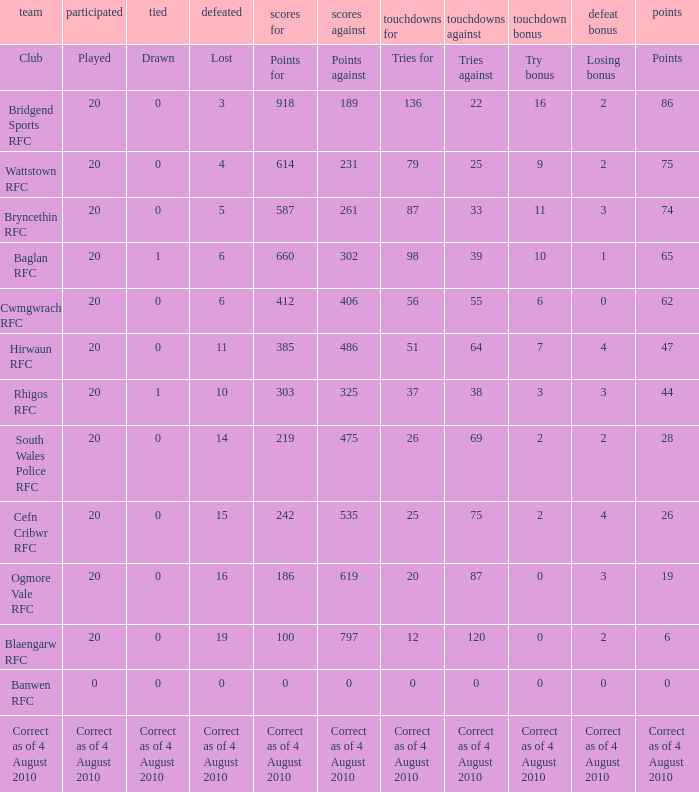What is the attempts for when forfeiting bonus is relinquishing bonus? Tries for. 